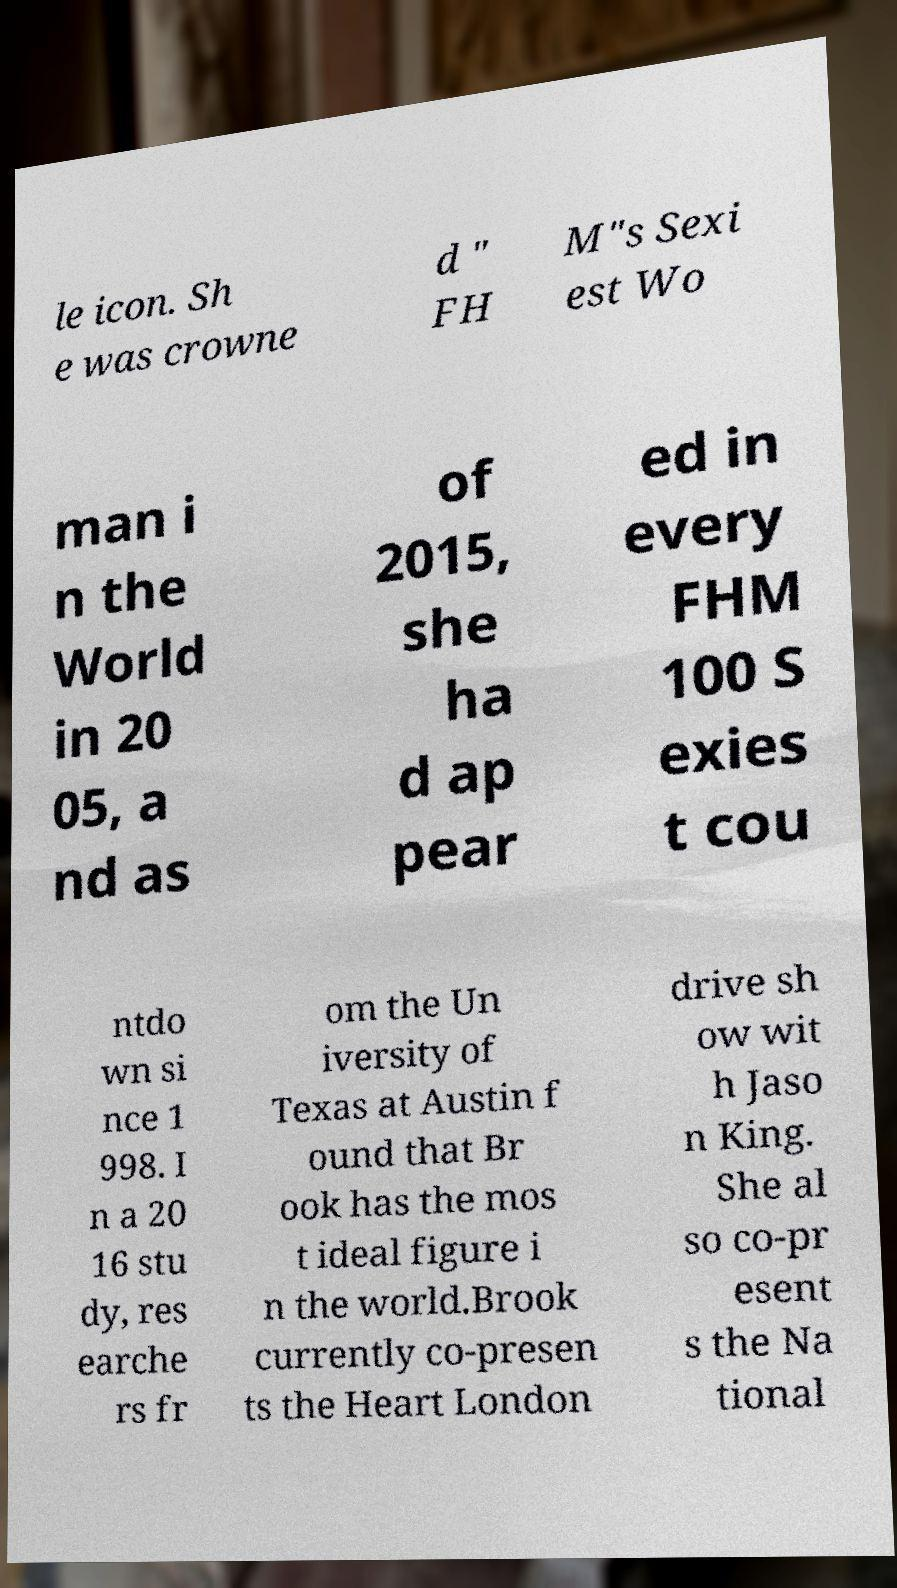There's text embedded in this image that I need extracted. Can you transcribe it verbatim? le icon. Sh e was crowne d " FH M"s Sexi est Wo man i n the World in 20 05, a nd as of 2015, she ha d ap pear ed in every FHM 100 S exies t cou ntdo wn si nce 1 998. I n a 20 16 stu dy, res earche rs fr om the Un iversity of Texas at Austin f ound that Br ook has the mos t ideal figure i n the world.Brook currently co-presen ts the Heart London drive sh ow wit h Jaso n King. She al so co-pr esent s the Na tional 